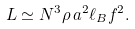Convert formula to latex. <formula><loc_0><loc_0><loc_500><loc_500>L \simeq N ^ { 3 } \rho \, a ^ { 2 } \ell _ { B } f ^ { 2 } .</formula> 